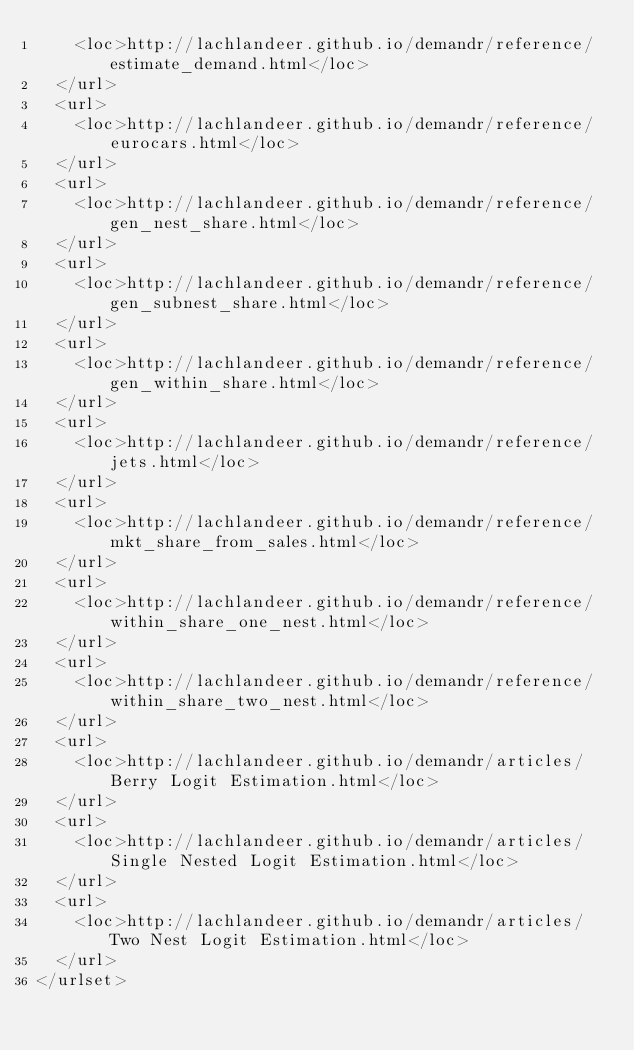<code> <loc_0><loc_0><loc_500><loc_500><_XML_>    <loc>http://lachlandeer.github.io/demandr/reference/estimate_demand.html</loc>
  </url>
  <url>
    <loc>http://lachlandeer.github.io/demandr/reference/eurocars.html</loc>
  </url>
  <url>
    <loc>http://lachlandeer.github.io/demandr/reference/gen_nest_share.html</loc>
  </url>
  <url>
    <loc>http://lachlandeer.github.io/demandr/reference/gen_subnest_share.html</loc>
  </url>
  <url>
    <loc>http://lachlandeer.github.io/demandr/reference/gen_within_share.html</loc>
  </url>
  <url>
    <loc>http://lachlandeer.github.io/demandr/reference/jets.html</loc>
  </url>
  <url>
    <loc>http://lachlandeer.github.io/demandr/reference/mkt_share_from_sales.html</loc>
  </url>
  <url>
    <loc>http://lachlandeer.github.io/demandr/reference/within_share_one_nest.html</loc>
  </url>
  <url>
    <loc>http://lachlandeer.github.io/demandr/reference/within_share_two_nest.html</loc>
  </url>
  <url>
    <loc>http://lachlandeer.github.io/demandr/articles/Berry Logit Estimation.html</loc>
  </url>
  <url>
    <loc>http://lachlandeer.github.io/demandr/articles/Single Nested Logit Estimation.html</loc>
  </url>
  <url>
    <loc>http://lachlandeer.github.io/demandr/articles/Two Nest Logit Estimation.html</loc>
  </url>
</urlset>
</code> 